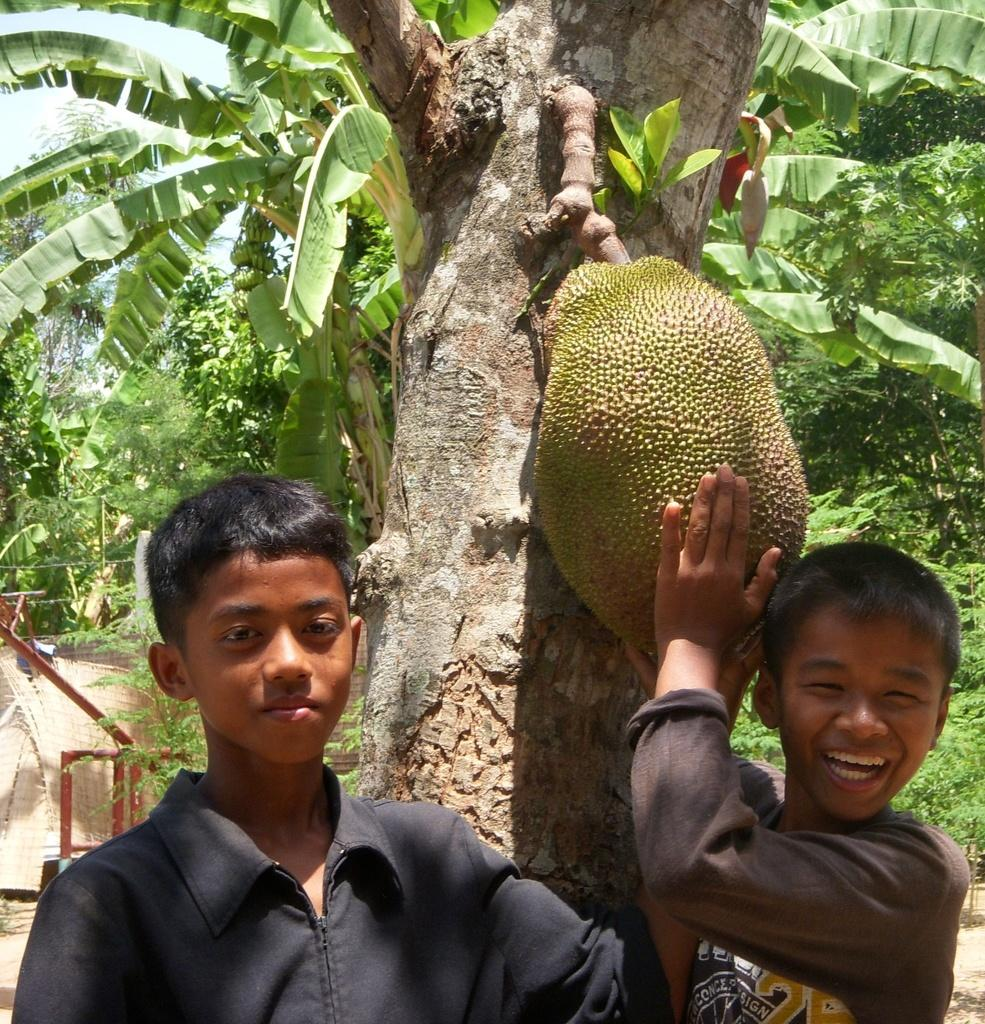How many kids are in the image? There are two kids in the image. What is one of the kids holding? One of the kids is holding a jack fruit. What is the jack fruit associated with? The jack fruit is associated with a tree. What type of brass instrument is the chicken playing in the image? There is no chicken or brass instrument present in the image. What type of paste is being used to stick the jack fruit to the tree in the image? There is no paste or indication of the jack fruit being stuck to the tree in the image. 